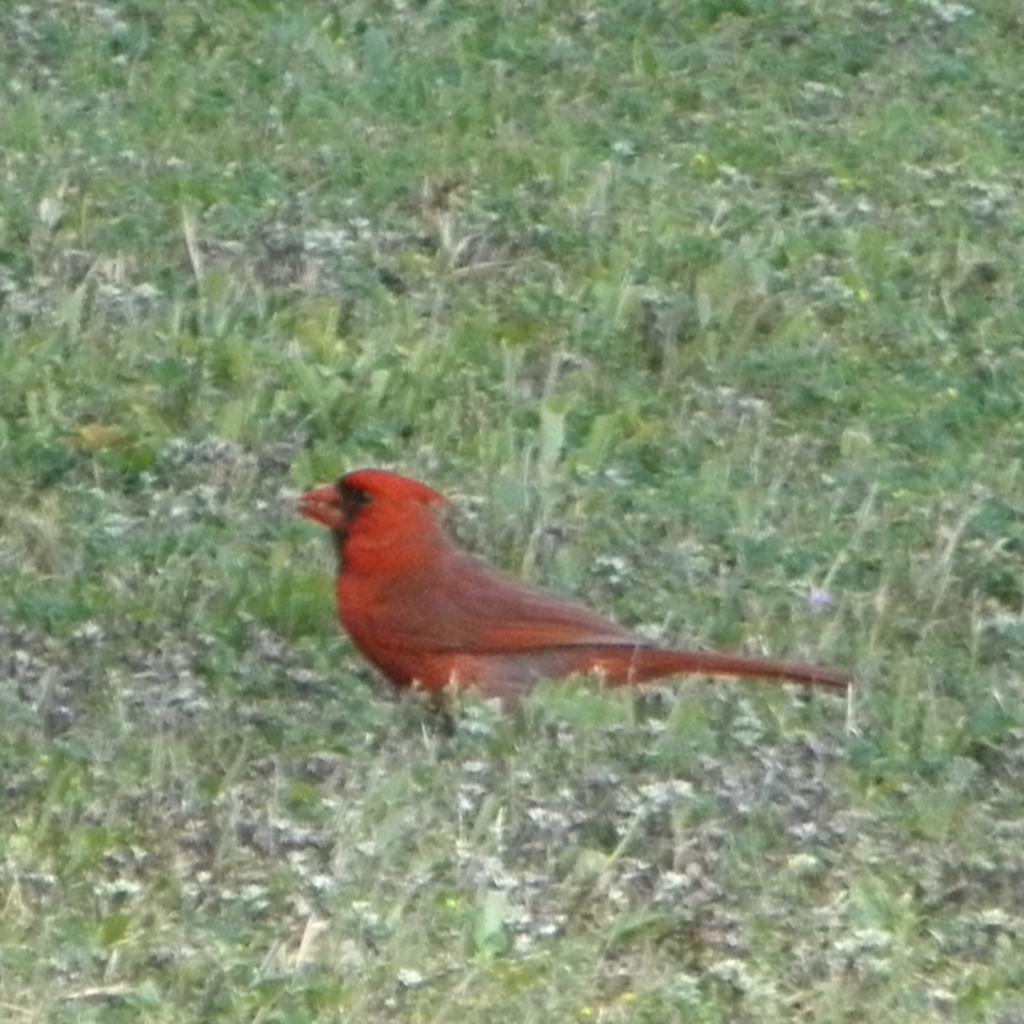What type of animal is present in the image? There is a bird in the image. What color is the bird? The bird is in orange color. Where is the bird located? The bird is in grass. What type of bottle is the bird using to teach in the image? There is no bottle or teaching activity present in the image; it features a bird in grass. 